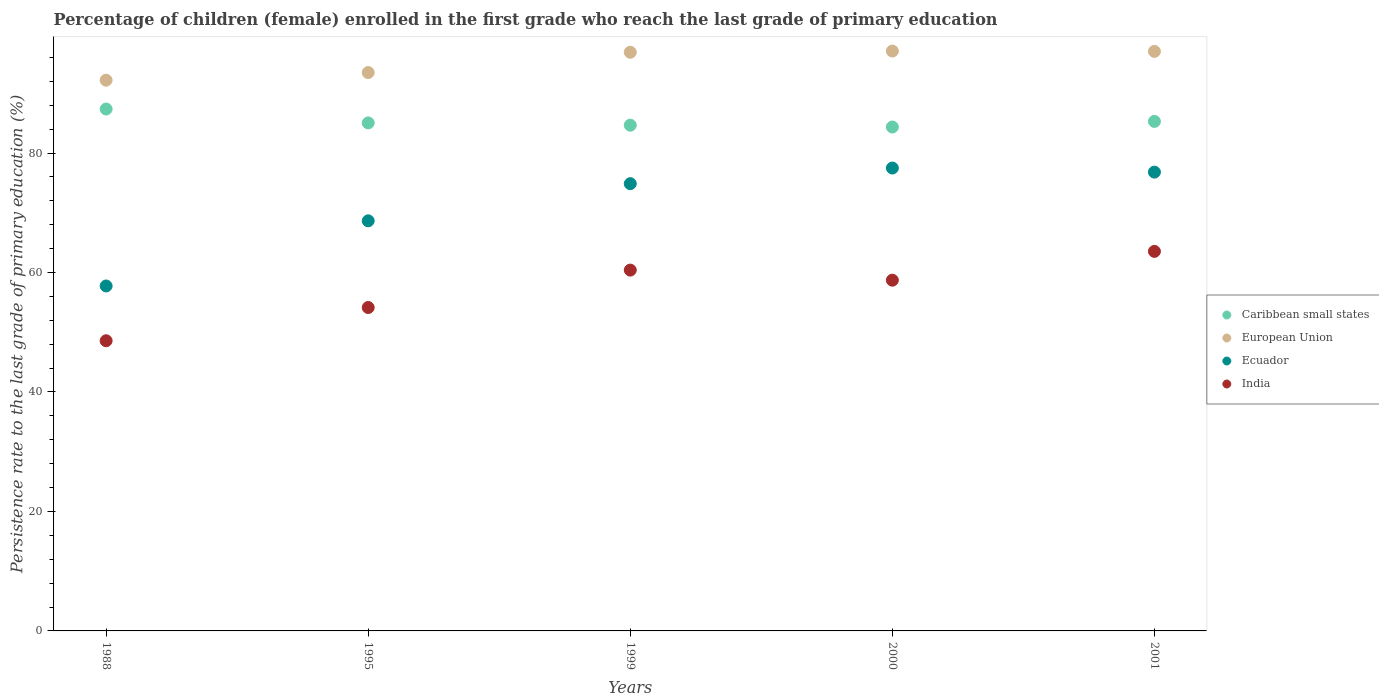Is the number of dotlines equal to the number of legend labels?
Ensure brevity in your answer.  Yes. What is the persistence rate of children in India in 2001?
Offer a terse response. 63.54. Across all years, what is the maximum persistence rate of children in Ecuador?
Give a very brief answer. 77.49. Across all years, what is the minimum persistence rate of children in Caribbean small states?
Give a very brief answer. 84.36. What is the total persistence rate of children in Ecuador in the graph?
Make the answer very short. 355.56. What is the difference between the persistence rate of children in Ecuador in 1999 and that in 2001?
Make the answer very short. -1.93. What is the difference between the persistence rate of children in Ecuador in 1988 and the persistence rate of children in India in 2001?
Ensure brevity in your answer.  -5.79. What is the average persistence rate of children in Ecuador per year?
Offer a very short reply. 71.11. In the year 2001, what is the difference between the persistence rate of children in India and persistence rate of children in Caribbean small states?
Provide a succinct answer. -21.76. In how many years, is the persistence rate of children in Caribbean small states greater than 92 %?
Your answer should be compact. 0. What is the ratio of the persistence rate of children in Caribbean small states in 1995 to that in 2000?
Give a very brief answer. 1.01. Is the difference between the persistence rate of children in India in 1995 and 2000 greater than the difference between the persistence rate of children in Caribbean small states in 1995 and 2000?
Provide a succinct answer. No. What is the difference between the highest and the second highest persistence rate of children in Caribbean small states?
Provide a short and direct response. 2.07. What is the difference between the highest and the lowest persistence rate of children in India?
Give a very brief answer. 14.96. Is the sum of the persistence rate of children in Caribbean small states in 1988 and 1999 greater than the maximum persistence rate of children in India across all years?
Give a very brief answer. Yes. Is the persistence rate of children in Ecuador strictly less than the persistence rate of children in European Union over the years?
Your response must be concise. Yes. What is the difference between two consecutive major ticks on the Y-axis?
Your response must be concise. 20. Does the graph contain grids?
Make the answer very short. No. How many legend labels are there?
Your answer should be compact. 4. What is the title of the graph?
Ensure brevity in your answer.  Percentage of children (female) enrolled in the first grade who reach the last grade of primary education. Does "Malta" appear as one of the legend labels in the graph?
Your answer should be compact. No. What is the label or title of the X-axis?
Offer a terse response. Years. What is the label or title of the Y-axis?
Offer a terse response. Persistence rate to the last grade of primary education (%). What is the Persistence rate to the last grade of primary education (%) in Caribbean small states in 1988?
Your answer should be compact. 87.37. What is the Persistence rate to the last grade of primary education (%) of European Union in 1988?
Make the answer very short. 92.19. What is the Persistence rate to the last grade of primary education (%) of Ecuador in 1988?
Your answer should be compact. 57.74. What is the Persistence rate to the last grade of primary education (%) in India in 1988?
Provide a short and direct response. 48.57. What is the Persistence rate to the last grade of primary education (%) in Caribbean small states in 1995?
Keep it short and to the point. 85.04. What is the Persistence rate to the last grade of primary education (%) of European Union in 1995?
Make the answer very short. 93.47. What is the Persistence rate to the last grade of primary education (%) of Ecuador in 1995?
Ensure brevity in your answer.  68.65. What is the Persistence rate to the last grade of primary education (%) of India in 1995?
Offer a very short reply. 54.14. What is the Persistence rate to the last grade of primary education (%) in Caribbean small states in 1999?
Your answer should be compact. 84.66. What is the Persistence rate to the last grade of primary education (%) in European Union in 1999?
Keep it short and to the point. 96.87. What is the Persistence rate to the last grade of primary education (%) in Ecuador in 1999?
Make the answer very short. 74.87. What is the Persistence rate to the last grade of primary education (%) of India in 1999?
Make the answer very short. 60.4. What is the Persistence rate to the last grade of primary education (%) in Caribbean small states in 2000?
Your answer should be compact. 84.36. What is the Persistence rate to the last grade of primary education (%) in European Union in 2000?
Your response must be concise. 97.07. What is the Persistence rate to the last grade of primary education (%) of Ecuador in 2000?
Keep it short and to the point. 77.49. What is the Persistence rate to the last grade of primary education (%) in India in 2000?
Provide a short and direct response. 58.71. What is the Persistence rate to the last grade of primary education (%) in Caribbean small states in 2001?
Your answer should be compact. 85.3. What is the Persistence rate to the last grade of primary education (%) in European Union in 2001?
Ensure brevity in your answer.  97.02. What is the Persistence rate to the last grade of primary education (%) in Ecuador in 2001?
Offer a terse response. 76.8. What is the Persistence rate to the last grade of primary education (%) of India in 2001?
Keep it short and to the point. 63.54. Across all years, what is the maximum Persistence rate to the last grade of primary education (%) in Caribbean small states?
Provide a short and direct response. 87.37. Across all years, what is the maximum Persistence rate to the last grade of primary education (%) of European Union?
Provide a short and direct response. 97.07. Across all years, what is the maximum Persistence rate to the last grade of primary education (%) in Ecuador?
Your answer should be very brief. 77.49. Across all years, what is the maximum Persistence rate to the last grade of primary education (%) in India?
Keep it short and to the point. 63.54. Across all years, what is the minimum Persistence rate to the last grade of primary education (%) in Caribbean small states?
Your answer should be very brief. 84.36. Across all years, what is the minimum Persistence rate to the last grade of primary education (%) of European Union?
Offer a terse response. 92.19. Across all years, what is the minimum Persistence rate to the last grade of primary education (%) in Ecuador?
Give a very brief answer. 57.74. Across all years, what is the minimum Persistence rate to the last grade of primary education (%) in India?
Provide a short and direct response. 48.57. What is the total Persistence rate to the last grade of primary education (%) in Caribbean small states in the graph?
Your answer should be very brief. 426.72. What is the total Persistence rate to the last grade of primary education (%) in European Union in the graph?
Offer a very short reply. 476.62. What is the total Persistence rate to the last grade of primary education (%) in Ecuador in the graph?
Make the answer very short. 355.56. What is the total Persistence rate to the last grade of primary education (%) in India in the graph?
Offer a terse response. 285.37. What is the difference between the Persistence rate to the last grade of primary education (%) in Caribbean small states in 1988 and that in 1995?
Provide a succinct answer. 2.32. What is the difference between the Persistence rate to the last grade of primary education (%) of European Union in 1988 and that in 1995?
Provide a succinct answer. -1.28. What is the difference between the Persistence rate to the last grade of primary education (%) of Ecuador in 1988 and that in 1995?
Your response must be concise. -10.91. What is the difference between the Persistence rate to the last grade of primary education (%) of India in 1988 and that in 1995?
Offer a terse response. -5.57. What is the difference between the Persistence rate to the last grade of primary education (%) of Caribbean small states in 1988 and that in 1999?
Provide a short and direct response. 2.71. What is the difference between the Persistence rate to the last grade of primary education (%) of European Union in 1988 and that in 1999?
Ensure brevity in your answer.  -4.68. What is the difference between the Persistence rate to the last grade of primary education (%) of Ecuador in 1988 and that in 1999?
Your answer should be compact. -17.13. What is the difference between the Persistence rate to the last grade of primary education (%) in India in 1988 and that in 1999?
Your response must be concise. -11.83. What is the difference between the Persistence rate to the last grade of primary education (%) of Caribbean small states in 1988 and that in 2000?
Keep it short and to the point. 3.01. What is the difference between the Persistence rate to the last grade of primary education (%) of European Union in 1988 and that in 2000?
Provide a short and direct response. -4.88. What is the difference between the Persistence rate to the last grade of primary education (%) of Ecuador in 1988 and that in 2000?
Offer a terse response. -19.74. What is the difference between the Persistence rate to the last grade of primary education (%) in India in 1988 and that in 2000?
Offer a terse response. -10.14. What is the difference between the Persistence rate to the last grade of primary education (%) in Caribbean small states in 1988 and that in 2001?
Your answer should be compact. 2.07. What is the difference between the Persistence rate to the last grade of primary education (%) of European Union in 1988 and that in 2001?
Provide a short and direct response. -4.82. What is the difference between the Persistence rate to the last grade of primary education (%) of Ecuador in 1988 and that in 2001?
Keep it short and to the point. -19.06. What is the difference between the Persistence rate to the last grade of primary education (%) in India in 1988 and that in 2001?
Offer a terse response. -14.96. What is the difference between the Persistence rate to the last grade of primary education (%) of Caribbean small states in 1995 and that in 1999?
Ensure brevity in your answer.  0.38. What is the difference between the Persistence rate to the last grade of primary education (%) of European Union in 1995 and that in 1999?
Your answer should be very brief. -3.4. What is the difference between the Persistence rate to the last grade of primary education (%) of Ecuador in 1995 and that in 1999?
Your answer should be very brief. -6.22. What is the difference between the Persistence rate to the last grade of primary education (%) of India in 1995 and that in 1999?
Offer a very short reply. -6.26. What is the difference between the Persistence rate to the last grade of primary education (%) of Caribbean small states in 1995 and that in 2000?
Your response must be concise. 0.69. What is the difference between the Persistence rate to the last grade of primary education (%) of European Union in 1995 and that in 2000?
Your answer should be very brief. -3.6. What is the difference between the Persistence rate to the last grade of primary education (%) of Ecuador in 1995 and that in 2000?
Make the answer very short. -8.84. What is the difference between the Persistence rate to the last grade of primary education (%) in India in 1995 and that in 2000?
Offer a terse response. -4.57. What is the difference between the Persistence rate to the last grade of primary education (%) in Caribbean small states in 1995 and that in 2001?
Give a very brief answer. -0.25. What is the difference between the Persistence rate to the last grade of primary education (%) of European Union in 1995 and that in 2001?
Your answer should be very brief. -3.54. What is the difference between the Persistence rate to the last grade of primary education (%) in Ecuador in 1995 and that in 2001?
Keep it short and to the point. -8.15. What is the difference between the Persistence rate to the last grade of primary education (%) of India in 1995 and that in 2001?
Provide a short and direct response. -9.4. What is the difference between the Persistence rate to the last grade of primary education (%) in Caribbean small states in 1999 and that in 2000?
Offer a terse response. 0.3. What is the difference between the Persistence rate to the last grade of primary education (%) in European Union in 1999 and that in 2000?
Provide a succinct answer. -0.2. What is the difference between the Persistence rate to the last grade of primary education (%) of Ecuador in 1999 and that in 2000?
Offer a terse response. -2.62. What is the difference between the Persistence rate to the last grade of primary education (%) of India in 1999 and that in 2000?
Give a very brief answer. 1.69. What is the difference between the Persistence rate to the last grade of primary education (%) in Caribbean small states in 1999 and that in 2001?
Ensure brevity in your answer.  -0.64. What is the difference between the Persistence rate to the last grade of primary education (%) in European Union in 1999 and that in 2001?
Offer a terse response. -0.15. What is the difference between the Persistence rate to the last grade of primary education (%) of Ecuador in 1999 and that in 2001?
Your answer should be compact. -1.93. What is the difference between the Persistence rate to the last grade of primary education (%) in India in 1999 and that in 2001?
Keep it short and to the point. -3.14. What is the difference between the Persistence rate to the last grade of primary education (%) in Caribbean small states in 2000 and that in 2001?
Your response must be concise. -0.94. What is the difference between the Persistence rate to the last grade of primary education (%) in European Union in 2000 and that in 2001?
Keep it short and to the point. 0.05. What is the difference between the Persistence rate to the last grade of primary education (%) of Ecuador in 2000 and that in 2001?
Keep it short and to the point. 0.68. What is the difference between the Persistence rate to the last grade of primary education (%) in India in 2000 and that in 2001?
Keep it short and to the point. -4.82. What is the difference between the Persistence rate to the last grade of primary education (%) in Caribbean small states in 1988 and the Persistence rate to the last grade of primary education (%) in European Union in 1995?
Keep it short and to the point. -6.11. What is the difference between the Persistence rate to the last grade of primary education (%) in Caribbean small states in 1988 and the Persistence rate to the last grade of primary education (%) in Ecuador in 1995?
Your response must be concise. 18.72. What is the difference between the Persistence rate to the last grade of primary education (%) of Caribbean small states in 1988 and the Persistence rate to the last grade of primary education (%) of India in 1995?
Your answer should be compact. 33.23. What is the difference between the Persistence rate to the last grade of primary education (%) of European Union in 1988 and the Persistence rate to the last grade of primary education (%) of Ecuador in 1995?
Your response must be concise. 23.54. What is the difference between the Persistence rate to the last grade of primary education (%) in European Union in 1988 and the Persistence rate to the last grade of primary education (%) in India in 1995?
Offer a terse response. 38.05. What is the difference between the Persistence rate to the last grade of primary education (%) in Ecuador in 1988 and the Persistence rate to the last grade of primary education (%) in India in 1995?
Make the answer very short. 3.6. What is the difference between the Persistence rate to the last grade of primary education (%) in Caribbean small states in 1988 and the Persistence rate to the last grade of primary education (%) in European Union in 1999?
Make the answer very short. -9.5. What is the difference between the Persistence rate to the last grade of primary education (%) in Caribbean small states in 1988 and the Persistence rate to the last grade of primary education (%) in Ecuador in 1999?
Keep it short and to the point. 12.49. What is the difference between the Persistence rate to the last grade of primary education (%) in Caribbean small states in 1988 and the Persistence rate to the last grade of primary education (%) in India in 1999?
Provide a succinct answer. 26.96. What is the difference between the Persistence rate to the last grade of primary education (%) in European Union in 1988 and the Persistence rate to the last grade of primary education (%) in Ecuador in 1999?
Offer a terse response. 17.32. What is the difference between the Persistence rate to the last grade of primary education (%) of European Union in 1988 and the Persistence rate to the last grade of primary education (%) of India in 1999?
Your response must be concise. 31.79. What is the difference between the Persistence rate to the last grade of primary education (%) of Ecuador in 1988 and the Persistence rate to the last grade of primary education (%) of India in 1999?
Give a very brief answer. -2.66. What is the difference between the Persistence rate to the last grade of primary education (%) in Caribbean small states in 1988 and the Persistence rate to the last grade of primary education (%) in European Union in 2000?
Keep it short and to the point. -9.7. What is the difference between the Persistence rate to the last grade of primary education (%) of Caribbean small states in 1988 and the Persistence rate to the last grade of primary education (%) of Ecuador in 2000?
Offer a terse response. 9.88. What is the difference between the Persistence rate to the last grade of primary education (%) in Caribbean small states in 1988 and the Persistence rate to the last grade of primary education (%) in India in 2000?
Give a very brief answer. 28.65. What is the difference between the Persistence rate to the last grade of primary education (%) of European Union in 1988 and the Persistence rate to the last grade of primary education (%) of Ecuador in 2000?
Your response must be concise. 14.71. What is the difference between the Persistence rate to the last grade of primary education (%) in European Union in 1988 and the Persistence rate to the last grade of primary education (%) in India in 2000?
Offer a very short reply. 33.48. What is the difference between the Persistence rate to the last grade of primary education (%) of Ecuador in 1988 and the Persistence rate to the last grade of primary education (%) of India in 2000?
Provide a short and direct response. -0.97. What is the difference between the Persistence rate to the last grade of primary education (%) of Caribbean small states in 1988 and the Persistence rate to the last grade of primary education (%) of European Union in 2001?
Make the answer very short. -9.65. What is the difference between the Persistence rate to the last grade of primary education (%) of Caribbean small states in 1988 and the Persistence rate to the last grade of primary education (%) of Ecuador in 2001?
Your response must be concise. 10.56. What is the difference between the Persistence rate to the last grade of primary education (%) of Caribbean small states in 1988 and the Persistence rate to the last grade of primary education (%) of India in 2001?
Your answer should be compact. 23.83. What is the difference between the Persistence rate to the last grade of primary education (%) in European Union in 1988 and the Persistence rate to the last grade of primary education (%) in Ecuador in 2001?
Offer a very short reply. 15.39. What is the difference between the Persistence rate to the last grade of primary education (%) in European Union in 1988 and the Persistence rate to the last grade of primary education (%) in India in 2001?
Your answer should be very brief. 28.66. What is the difference between the Persistence rate to the last grade of primary education (%) in Ecuador in 1988 and the Persistence rate to the last grade of primary education (%) in India in 2001?
Offer a terse response. -5.79. What is the difference between the Persistence rate to the last grade of primary education (%) of Caribbean small states in 1995 and the Persistence rate to the last grade of primary education (%) of European Union in 1999?
Ensure brevity in your answer.  -11.83. What is the difference between the Persistence rate to the last grade of primary education (%) of Caribbean small states in 1995 and the Persistence rate to the last grade of primary education (%) of Ecuador in 1999?
Give a very brief answer. 10.17. What is the difference between the Persistence rate to the last grade of primary education (%) of Caribbean small states in 1995 and the Persistence rate to the last grade of primary education (%) of India in 1999?
Make the answer very short. 24.64. What is the difference between the Persistence rate to the last grade of primary education (%) in European Union in 1995 and the Persistence rate to the last grade of primary education (%) in Ecuador in 1999?
Provide a succinct answer. 18.6. What is the difference between the Persistence rate to the last grade of primary education (%) of European Union in 1995 and the Persistence rate to the last grade of primary education (%) of India in 1999?
Provide a short and direct response. 33.07. What is the difference between the Persistence rate to the last grade of primary education (%) in Ecuador in 1995 and the Persistence rate to the last grade of primary education (%) in India in 1999?
Offer a very short reply. 8.25. What is the difference between the Persistence rate to the last grade of primary education (%) in Caribbean small states in 1995 and the Persistence rate to the last grade of primary education (%) in European Union in 2000?
Offer a terse response. -12.03. What is the difference between the Persistence rate to the last grade of primary education (%) of Caribbean small states in 1995 and the Persistence rate to the last grade of primary education (%) of Ecuador in 2000?
Keep it short and to the point. 7.56. What is the difference between the Persistence rate to the last grade of primary education (%) of Caribbean small states in 1995 and the Persistence rate to the last grade of primary education (%) of India in 2000?
Provide a succinct answer. 26.33. What is the difference between the Persistence rate to the last grade of primary education (%) of European Union in 1995 and the Persistence rate to the last grade of primary education (%) of Ecuador in 2000?
Provide a short and direct response. 15.99. What is the difference between the Persistence rate to the last grade of primary education (%) in European Union in 1995 and the Persistence rate to the last grade of primary education (%) in India in 2000?
Your answer should be compact. 34.76. What is the difference between the Persistence rate to the last grade of primary education (%) of Ecuador in 1995 and the Persistence rate to the last grade of primary education (%) of India in 2000?
Keep it short and to the point. 9.94. What is the difference between the Persistence rate to the last grade of primary education (%) of Caribbean small states in 1995 and the Persistence rate to the last grade of primary education (%) of European Union in 2001?
Offer a terse response. -11.97. What is the difference between the Persistence rate to the last grade of primary education (%) in Caribbean small states in 1995 and the Persistence rate to the last grade of primary education (%) in Ecuador in 2001?
Your response must be concise. 8.24. What is the difference between the Persistence rate to the last grade of primary education (%) in Caribbean small states in 1995 and the Persistence rate to the last grade of primary education (%) in India in 2001?
Offer a very short reply. 21.51. What is the difference between the Persistence rate to the last grade of primary education (%) in European Union in 1995 and the Persistence rate to the last grade of primary education (%) in Ecuador in 2001?
Offer a very short reply. 16.67. What is the difference between the Persistence rate to the last grade of primary education (%) of European Union in 1995 and the Persistence rate to the last grade of primary education (%) of India in 2001?
Your answer should be very brief. 29.94. What is the difference between the Persistence rate to the last grade of primary education (%) of Ecuador in 1995 and the Persistence rate to the last grade of primary education (%) of India in 2001?
Offer a very short reply. 5.11. What is the difference between the Persistence rate to the last grade of primary education (%) of Caribbean small states in 1999 and the Persistence rate to the last grade of primary education (%) of European Union in 2000?
Give a very brief answer. -12.41. What is the difference between the Persistence rate to the last grade of primary education (%) in Caribbean small states in 1999 and the Persistence rate to the last grade of primary education (%) in Ecuador in 2000?
Make the answer very short. 7.17. What is the difference between the Persistence rate to the last grade of primary education (%) of Caribbean small states in 1999 and the Persistence rate to the last grade of primary education (%) of India in 2000?
Offer a terse response. 25.95. What is the difference between the Persistence rate to the last grade of primary education (%) of European Union in 1999 and the Persistence rate to the last grade of primary education (%) of Ecuador in 2000?
Offer a terse response. 19.38. What is the difference between the Persistence rate to the last grade of primary education (%) in European Union in 1999 and the Persistence rate to the last grade of primary education (%) in India in 2000?
Keep it short and to the point. 38.16. What is the difference between the Persistence rate to the last grade of primary education (%) of Ecuador in 1999 and the Persistence rate to the last grade of primary education (%) of India in 2000?
Your response must be concise. 16.16. What is the difference between the Persistence rate to the last grade of primary education (%) of Caribbean small states in 1999 and the Persistence rate to the last grade of primary education (%) of European Union in 2001?
Keep it short and to the point. -12.35. What is the difference between the Persistence rate to the last grade of primary education (%) of Caribbean small states in 1999 and the Persistence rate to the last grade of primary education (%) of Ecuador in 2001?
Make the answer very short. 7.86. What is the difference between the Persistence rate to the last grade of primary education (%) of Caribbean small states in 1999 and the Persistence rate to the last grade of primary education (%) of India in 2001?
Ensure brevity in your answer.  21.12. What is the difference between the Persistence rate to the last grade of primary education (%) in European Union in 1999 and the Persistence rate to the last grade of primary education (%) in Ecuador in 2001?
Keep it short and to the point. 20.07. What is the difference between the Persistence rate to the last grade of primary education (%) in European Union in 1999 and the Persistence rate to the last grade of primary education (%) in India in 2001?
Make the answer very short. 33.33. What is the difference between the Persistence rate to the last grade of primary education (%) of Ecuador in 1999 and the Persistence rate to the last grade of primary education (%) of India in 2001?
Offer a terse response. 11.33. What is the difference between the Persistence rate to the last grade of primary education (%) in Caribbean small states in 2000 and the Persistence rate to the last grade of primary education (%) in European Union in 2001?
Offer a very short reply. -12.66. What is the difference between the Persistence rate to the last grade of primary education (%) of Caribbean small states in 2000 and the Persistence rate to the last grade of primary education (%) of Ecuador in 2001?
Provide a short and direct response. 7.55. What is the difference between the Persistence rate to the last grade of primary education (%) of Caribbean small states in 2000 and the Persistence rate to the last grade of primary education (%) of India in 2001?
Your answer should be very brief. 20.82. What is the difference between the Persistence rate to the last grade of primary education (%) in European Union in 2000 and the Persistence rate to the last grade of primary education (%) in Ecuador in 2001?
Your answer should be very brief. 20.27. What is the difference between the Persistence rate to the last grade of primary education (%) in European Union in 2000 and the Persistence rate to the last grade of primary education (%) in India in 2001?
Keep it short and to the point. 33.53. What is the difference between the Persistence rate to the last grade of primary education (%) of Ecuador in 2000 and the Persistence rate to the last grade of primary education (%) of India in 2001?
Offer a terse response. 13.95. What is the average Persistence rate to the last grade of primary education (%) in Caribbean small states per year?
Your answer should be compact. 85.34. What is the average Persistence rate to the last grade of primary education (%) of European Union per year?
Offer a terse response. 95.32. What is the average Persistence rate to the last grade of primary education (%) of Ecuador per year?
Make the answer very short. 71.11. What is the average Persistence rate to the last grade of primary education (%) in India per year?
Offer a terse response. 57.07. In the year 1988, what is the difference between the Persistence rate to the last grade of primary education (%) of Caribbean small states and Persistence rate to the last grade of primary education (%) of European Union?
Provide a short and direct response. -4.83. In the year 1988, what is the difference between the Persistence rate to the last grade of primary education (%) in Caribbean small states and Persistence rate to the last grade of primary education (%) in Ecuador?
Offer a terse response. 29.62. In the year 1988, what is the difference between the Persistence rate to the last grade of primary education (%) of Caribbean small states and Persistence rate to the last grade of primary education (%) of India?
Offer a very short reply. 38.79. In the year 1988, what is the difference between the Persistence rate to the last grade of primary education (%) in European Union and Persistence rate to the last grade of primary education (%) in Ecuador?
Your answer should be compact. 34.45. In the year 1988, what is the difference between the Persistence rate to the last grade of primary education (%) of European Union and Persistence rate to the last grade of primary education (%) of India?
Ensure brevity in your answer.  43.62. In the year 1988, what is the difference between the Persistence rate to the last grade of primary education (%) of Ecuador and Persistence rate to the last grade of primary education (%) of India?
Keep it short and to the point. 9.17. In the year 1995, what is the difference between the Persistence rate to the last grade of primary education (%) in Caribbean small states and Persistence rate to the last grade of primary education (%) in European Union?
Keep it short and to the point. -8.43. In the year 1995, what is the difference between the Persistence rate to the last grade of primary education (%) of Caribbean small states and Persistence rate to the last grade of primary education (%) of Ecuador?
Provide a short and direct response. 16.39. In the year 1995, what is the difference between the Persistence rate to the last grade of primary education (%) of Caribbean small states and Persistence rate to the last grade of primary education (%) of India?
Make the answer very short. 30.9. In the year 1995, what is the difference between the Persistence rate to the last grade of primary education (%) of European Union and Persistence rate to the last grade of primary education (%) of Ecuador?
Offer a very short reply. 24.82. In the year 1995, what is the difference between the Persistence rate to the last grade of primary education (%) of European Union and Persistence rate to the last grade of primary education (%) of India?
Give a very brief answer. 39.33. In the year 1995, what is the difference between the Persistence rate to the last grade of primary education (%) of Ecuador and Persistence rate to the last grade of primary education (%) of India?
Provide a succinct answer. 14.51. In the year 1999, what is the difference between the Persistence rate to the last grade of primary education (%) of Caribbean small states and Persistence rate to the last grade of primary education (%) of European Union?
Your answer should be compact. -12.21. In the year 1999, what is the difference between the Persistence rate to the last grade of primary education (%) of Caribbean small states and Persistence rate to the last grade of primary education (%) of Ecuador?
Offer a very short reply. 9.79. In the year 1999, what is the difference between the Persistence rate to the last grade of primary education (%) of Caribbean small states and Persistence rate to the last grade of primary education (%) of India?
Provide a succinct answer. 24.26. In the year 1999, what is the difference between the Persistence rate to the last grade of primary education (%) of European Union and Persistence rate to the last grade of primary education (%) of Ecuador?
Keep it short and to the point. 22. In the year 1999, what is the difference between the Persistence rate to the last grade of primary education (%) in European Union and Persistence rate to the last grade of primary education (%) in India?
Your answer should be compact. 36.47. In the year 1999, what is the difference between the Persistence rate to the last grade of primary education (%) in Ecuador and Persistence rate to the last grade of primary education (%) in India?
Offer a terse response. 14.47. In the year 2000, what is the difference between the Persistence rate to the last grade of primary education (%) of Caribbean small states and Persistence rate to the last grade of primary education (%) of European Union?
Offer a terse response. -12.71. In the year 2000, what is the difference between the Persistence rate to the last grade of primary education (%) in Caribbean small states and Persistence rate to the last grade of primary education (%) in Ecuador?
Give a very brief answer. 6.87. In the year 2000, what is the difference between the Persistence rate to the last grade of primary education (%) of Caribbean small states and Persistence rate to the last grade of primary education (%) of India?
Your answer should be compact. 25.64. In the year 2000, what is the difference between the Persistence rate to the last grade of primary education (%) of European Union and Persistence rate to the last grade of primary education (%) of Ecuador?
Provide a short and direct response. 19.58. In the year 2000, what is the difference between the Persistence rate to the last grade of primary education (%) in European Union and Persistence rate to the last grade of primary education (%) in India?
Give a very brief answer. 38.36. In the year 2000, what is the difference between the Persistence rate to the last grade of primary education (%) in Ecuador and Persistence rate to the last grade of primary education (%) in India?
Make the answer very short. 18.77. In the year 2001, what is the difference between the Persistence rate to the last grade of primary education (%) of Caribbean small states and Persistence rate to the last grade of primary education (%) of European Union?
Offer a terse response. -11.72. In the year 2001, what is the difference between the Persistence rate to the last grade of primary education (%) of Caribbean small states and Persistence rate to the last grade of primary education (%) of Ecuador?
Your response must be concise. 8.49. In the year 2001, what is the difference between the Persistence rate to the last grade of primary education (%) in Caribbean small states and Persistence rate to the last grade of primary education (%) in India?
Your answer should be very brief. 21.76. In the year 2001, what is the difference between the Persistence rate to the last grade of primary education (%) of European Union and Persistence rate to the last grade of primary education (%) of Ecuador?
Offer a terse response. 20.21. In the year 2001, what is the difference between the Persistence rate to the last grade of primary education (%) in European Union and Persistence rate to the last grade of primary education (%) in India?
Keep it short and to the point. 33.48. In the year 2001, what is the difference between the Persistence rate to the last grade of primary education (%) in Ecuador and Persistence rate to the last grade of primary education (%) in India?
Your response must be concise. 13.27. What is the ratio of the Persistence rate to the last grade of primary education (%) in Caribbean small states in 1988 to that in 1995?
Your answer should be compact. 1.03. What is the ratio of the Persistence rate to the last grade of primary education (%) in European Union in 1988 to that in 1995?
Provide a succinct answer. 0.99. What is the ratio of the Persistence rate to the last grade of primary education (%) of Ecuador in 1988 to that in 1995?
Your answer should be compact. 0.84. What is the ratio of the Persistence rate to the last grade of primary education (%) of India in 1988 to that in 1995?
Your answer should be very brief. 0.9. What is the ratio of the Persistence rate to the last grade of primary education (%) in Caribbean small states in 1988 to that in 1999?
Your answer should be very brief. 1.03. What is the ratio of the Persistence rate to the last grade of primary education (%) in European Union in 1988 to that in 1999?
Provide a succinct answer. 0.95. What is the ratio of the Persistence rate to the last grade of primary education (%) of Ecuador in 1988 to that in 1999?
Offer a terse response. 0.77. What is the ratio of the Persistence rate to the last grade of primary education (%) of India in 1988 to that in 1999?
Ensure brevity in your answer.  0.8. What is the ratio of the Persistence rate to the last grade of primary education (%) in Caribbean small states in 1988 to that in 2000?
Your answer should be very brief. 1.04. What is the ratio of the Persistence rate to the last grade of primary education (%) in European Union in 1988 to that in 2000?
Your answer should be compact. 0.95. What is the ratio of the Persistence rate to the last grade of primary education (%) of Ecuador in 1988 to that in 2000?
Your answer should be compact. 0.75. What is the ratio of the Persistence rate to the last grade of primary education (%) of India in 1988 to that in 2000?
Ensure brevity in your answer.  0.83. What is the ratio of the Persistence rate to the last grade of primary education (%) in Caribbean small states in 1988 to that in 2001?
Keep it short and to the point. 1.02. What is the ratio of the Persistence rate to the last grade of primary education (%) in European Union in 1988 to that in 2001?
Offer a terse response. 0.95. What is the ratio of the Persistence rate to the last grade of primary education (%) in Ecuador in 1988 to that in 2001?
Keep it short and to the point. 0.75. What is the ratio of the Persistence rate to the last grade of primary education (%) in India in 1988 to that in 2001?
Offer a terse response. 0.76. What is the ratio of the Persistence rate to the last grade of primary education (%) in European Union in 1995 to that in 1999?
Provide a succinct answer. 0.96. What is the ratio of the Persistence rate to the last grade of primary education (%) of Ecuador in 1995 to that in 1999?
Your answer should be compact. 0.92. What is the ratio of the Persistence rate to the last grade of primary education (%) in India in 1995 to that in 1999?
Provide a succinct answer. 0.9. What is the ratio of the Persistence rate to the last grade of primary education (%) of Caribbean small states in 1995 to that in 2000?
Offer a very short reply. 1.01. What is the ratio of the Persistence rate to the last grade of primary education (%) in Ecuador in 1995 to that in 2000?
Provide a short and direct response. 0.89. What is the ratio of the Persistence rate to the last grade of primary education (%) in India in 1995 to that in 2000?
Keep it short and to the point. 0.92. What is the ratio of the Persistence rate to the last grade of primary education (%) of Caribbean small states in 1995 to that in 2001?
Make the answer very short. 1. What is the ratio of the Persistence rate to the last grade of primary education (%) in European Union in 1995 to that in 2001?
Provide a succinct answer. 0.96. What is the ratio of the Persistence rate to the last grade of primary education (%) in Ecuador in 1995 to that in 2001?
Ensure brevity in your answer.  0.89. What is the ratio of the Persistence rate to the last grade of primary education (%) in India in 1995 to that in 2001?
Offer a very short reply. 0.85. What is the ratio of the Persistence rate to the last grade of primary education (%) in Caribbean small states in 1999 to that in 2000?
Offer a terse response. 1. What is the ratio of the Persistence rate to the last grade of primary education (%) of European Union in 1999 to that in 2000?
Offer a terse response. 1. What is the ratio of the Persistence rate to the last grade of primary education (%) in Ecuador in 1999 to that in 2000?
Offer a very short reply. 0.97. What is the ratio of the Persistence rate to the last grade of primary education (%) in India in 1999 to that in 2000?
Keep it short and to the point. 1.03. What is the ratio of the Persistence rate to the last grade of primary education (%) in Ecuador in 1999 to that in 2001?
Offer a very short reply. 0.97. What is the ratio of the Persistence rate to the last grade of primary education (%) of India in 1999 to that in 2001?
Offer a very short reply. 0.95. What is the ratio of the Persistence rate to the last grade of primary education (%) of Caribbean small states in 2000 to that in 2001?
Offer a terse response. 0.99. What is the ratio of the Persistence rate to the last grade of primary education (%) of Ecuador in 2000 to that in 2001?
Your answer should be very brief. 1.01. What is the ratio of the Persistence rate to the last grade of primary education (%) in India in 2000 to that in 2001?
Provide a succinct answer. 0.92. What is the difference between the highest and the second highest Persistence rate to the last grade of primary education (%) of Caribbean small states?
Offer a very short reply. 2.07. What is the difference between the highest and the second highest Persistence rate to the last grade of primary education (%) in European Union?
Offer a very short reply. 0.05. What is the difference between the highest and the second highest Persistence rate to the last grade of primary education (%) in Ecuador?
Your answer should be very brief. 0.68. What is the difference between the highest and the second highest Persistence rate to the last grade of primary education (%) in India?
Provide a succinct answer. 3.14. What is the difference between the highest and the lowest Persistence rate to the last grade of primary education (%) of Caribbean small states?
Give a very brief answer. 3.01. What is the difference between the highest and the lowest Persistence rate to the last grade of primary education (%) in European Union?
Your response must be concise. 4.88. What is the difference between the highest and the lowest Persistence rate to the last grade of primary education (%) in Ecuador?
Offer a very short reply. 19.74. What is the difference between the highest and the lowest Persistence rate to the last grade of primary education (%) of India?
Ensure brevity in your answer.  14.96. 